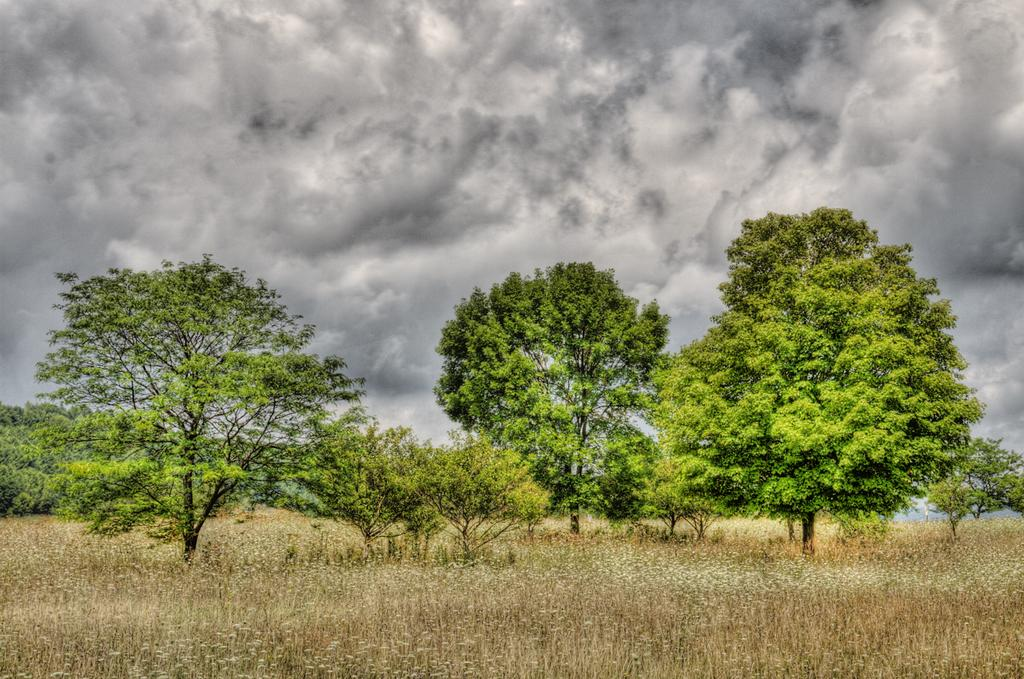What type of vegetation can be seen in the image? There are trees in the image. What is on the ground in the image? There is grass on the ground in the image. What part of the natural environment is visible in the image? The sky is visible in the image. What can be seen in the sky in the image? Clouds are present in the sky. What type of veil is covering the trees in the image? There is no veil present in the image; the trees are not covered. What shape is the grass forming in the image? The grass is not forming any specific shape in the image; it is simply covering the ground. 